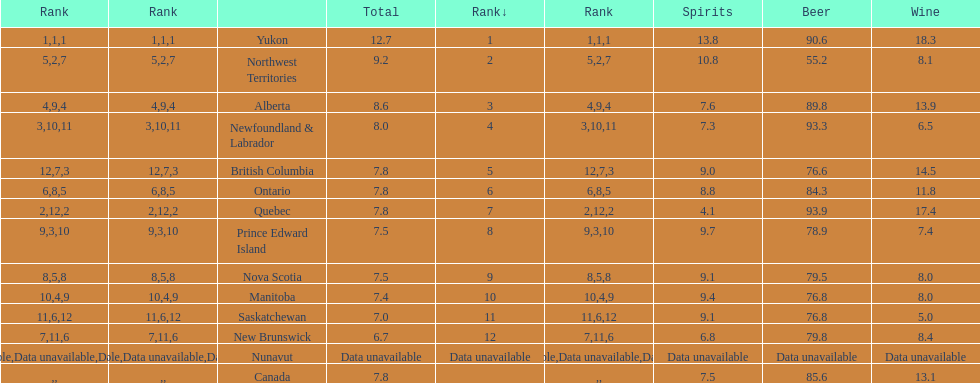How many litres do individuals in yukon consume in spirits per year? 12.7. 